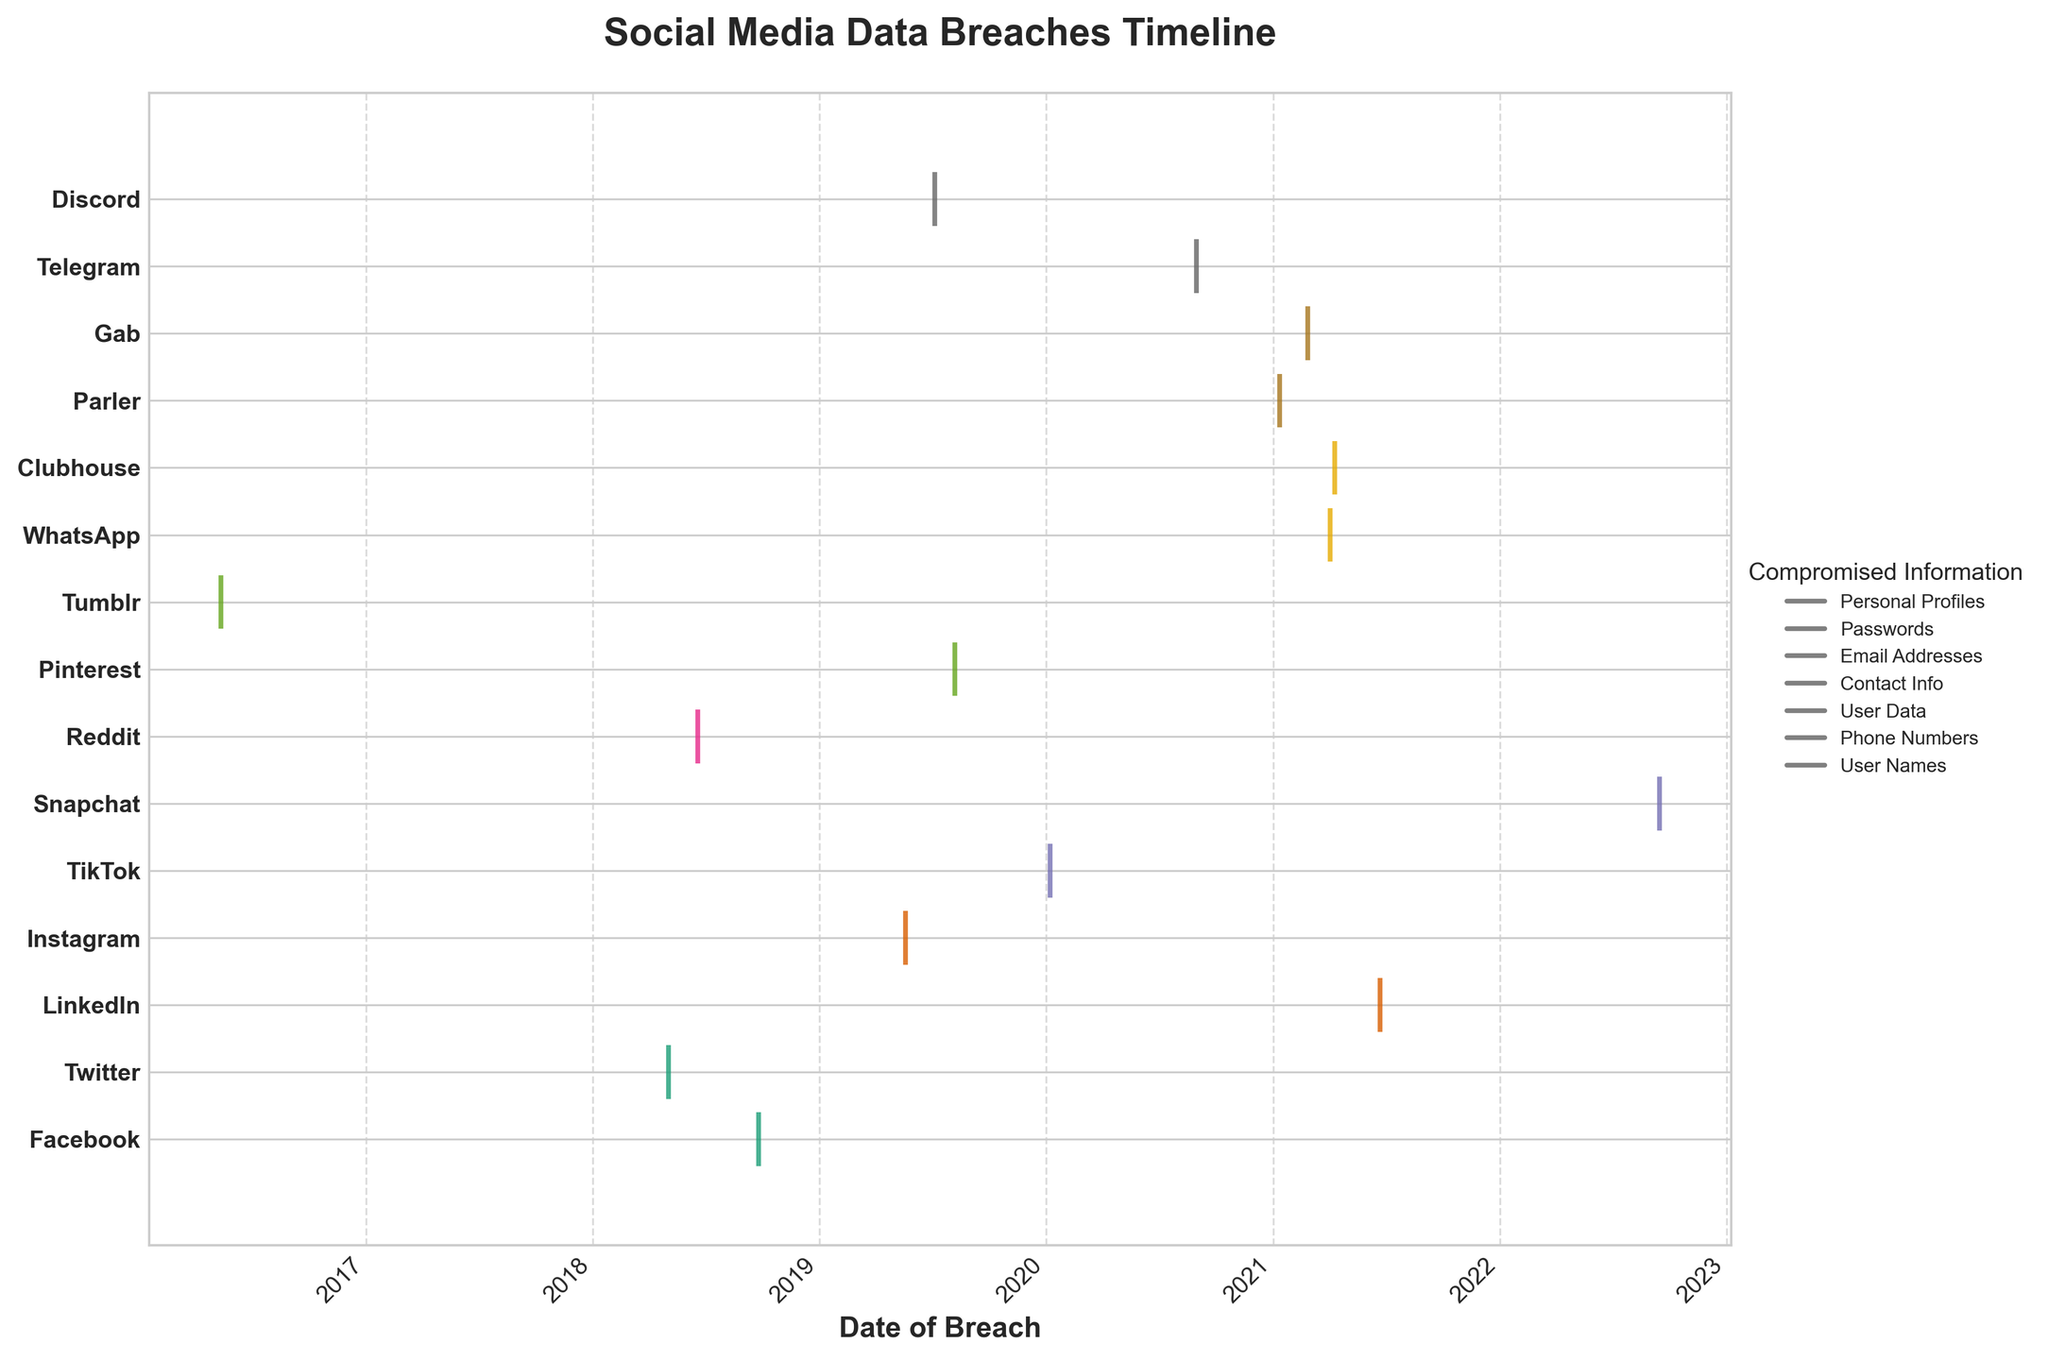What is the title of the plot? The title is typically positioned at the top of the plot and is labeled in bold. From the code, it is noted to be 'Social Media Data Breaches Timeline'.
Answer: Social Media Data Breaches Timeline Which platform had the earliest data breach? By looking at the x-axis starting from the leftmost point and finding the earliest date, the associated y-tick labeled will show the platform. According to the data, Tumblr has a breach on 2016-05-12, making it the earliest.
Answer: Tumblr How many platforms experienced data breaches in 2021? Check each y-tick for platforms with breach events occurring in 2021 by looking at the x-axis and matching dates with year 2021. According to the data: LinkedIn, WhatsApp, Clubhouse, Parler, Gab—all experienced breaches in 2021.
Answer: 5 Which type of information was most frequently compromised? Look at the legend which lists different types of compromised information, then count how often each type appears in the data. Phone numbers, email addresses, personal profiles, passwords, user data, contact info, and user names are the types. Phone numbers and email addresses each appear thrice.
Answer: Phone numbers / Email addresses Was there a data breach in the year 2020? If so, name the platforms affected. Scan across to 2020 on the x-axis and identify which platforms have events plotted in this year. According to the data, TikTok and Telegram experienced breaches in 2020.
Answer: TikTok, Telegram Compare the number of breaches in 2018 to the number of breaches in 2019. Which year had more breaches? Count the breaches for 2018 by checking events plotted in this year on the x-axis and repeating for 2019. For 2018: Facebook, Twitter, Reddit (total 3). For 2019: Instagram, Pinterest, Discord (total 3). Both years had the same number of breaches.
Answer: Equal Which platform had breaches involving 'personal_profiles'? Identify the symbol given to 'personal_profiles' in the legend. Cross-reference it with the breaches listed for each platform, finding the relevant platforms. According to the data, Facebook and Clubhouse had breaches involving 'personal_profiles'.
Answer: Facebook, Clubhouse Did any platforms experience more than one data breach? Check the vertical alignment for each y-tick to see if there are multiple events plotted for any single platform. According to the data, no platform experienced more than one data breach within the given period.
Answer: No 